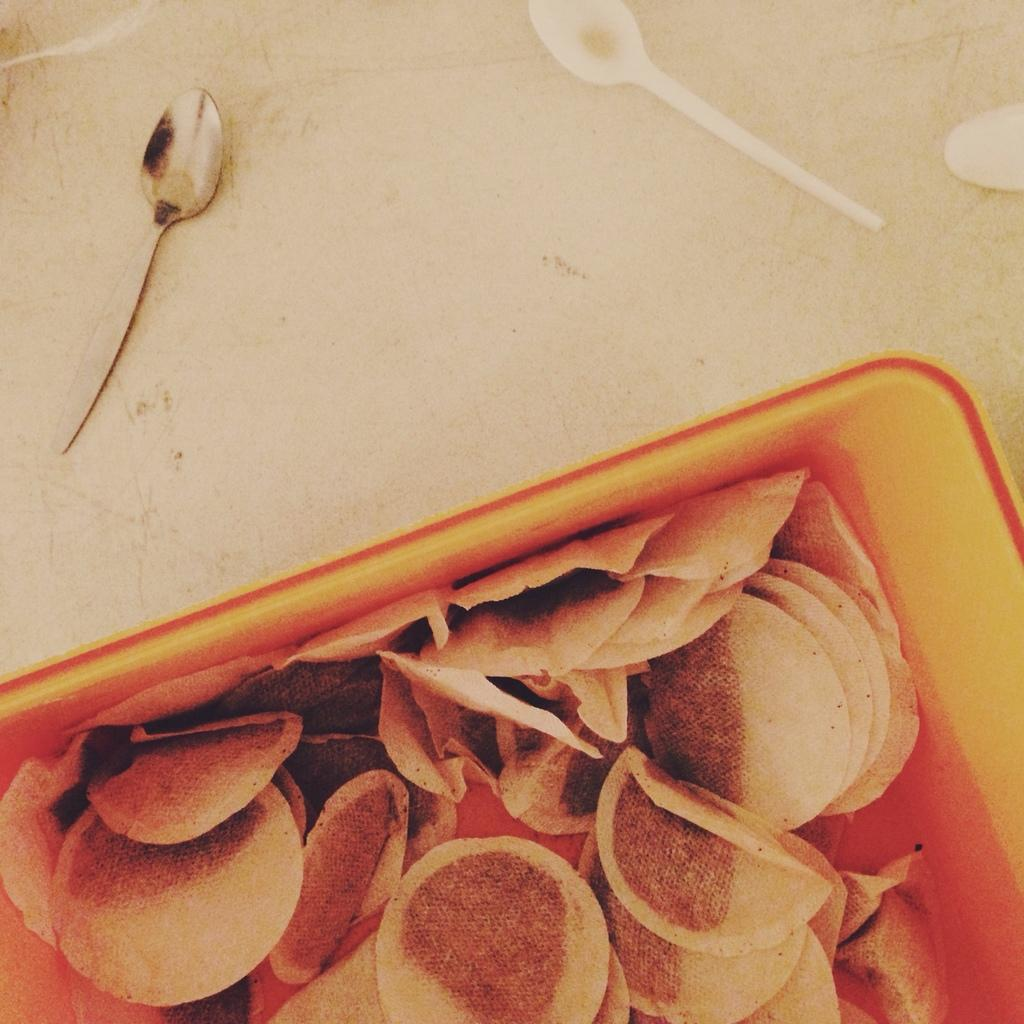What type of objects can be seen at the bottom of the image? There are food items in the image. How many spoons are present in the image? There are three spoons in the image. Where are the spoons located? The spoons are on a table. What type of brick is used to build the table in the image? There is no table present in the image, so it is not possible to determine the type of brick used to build it. 